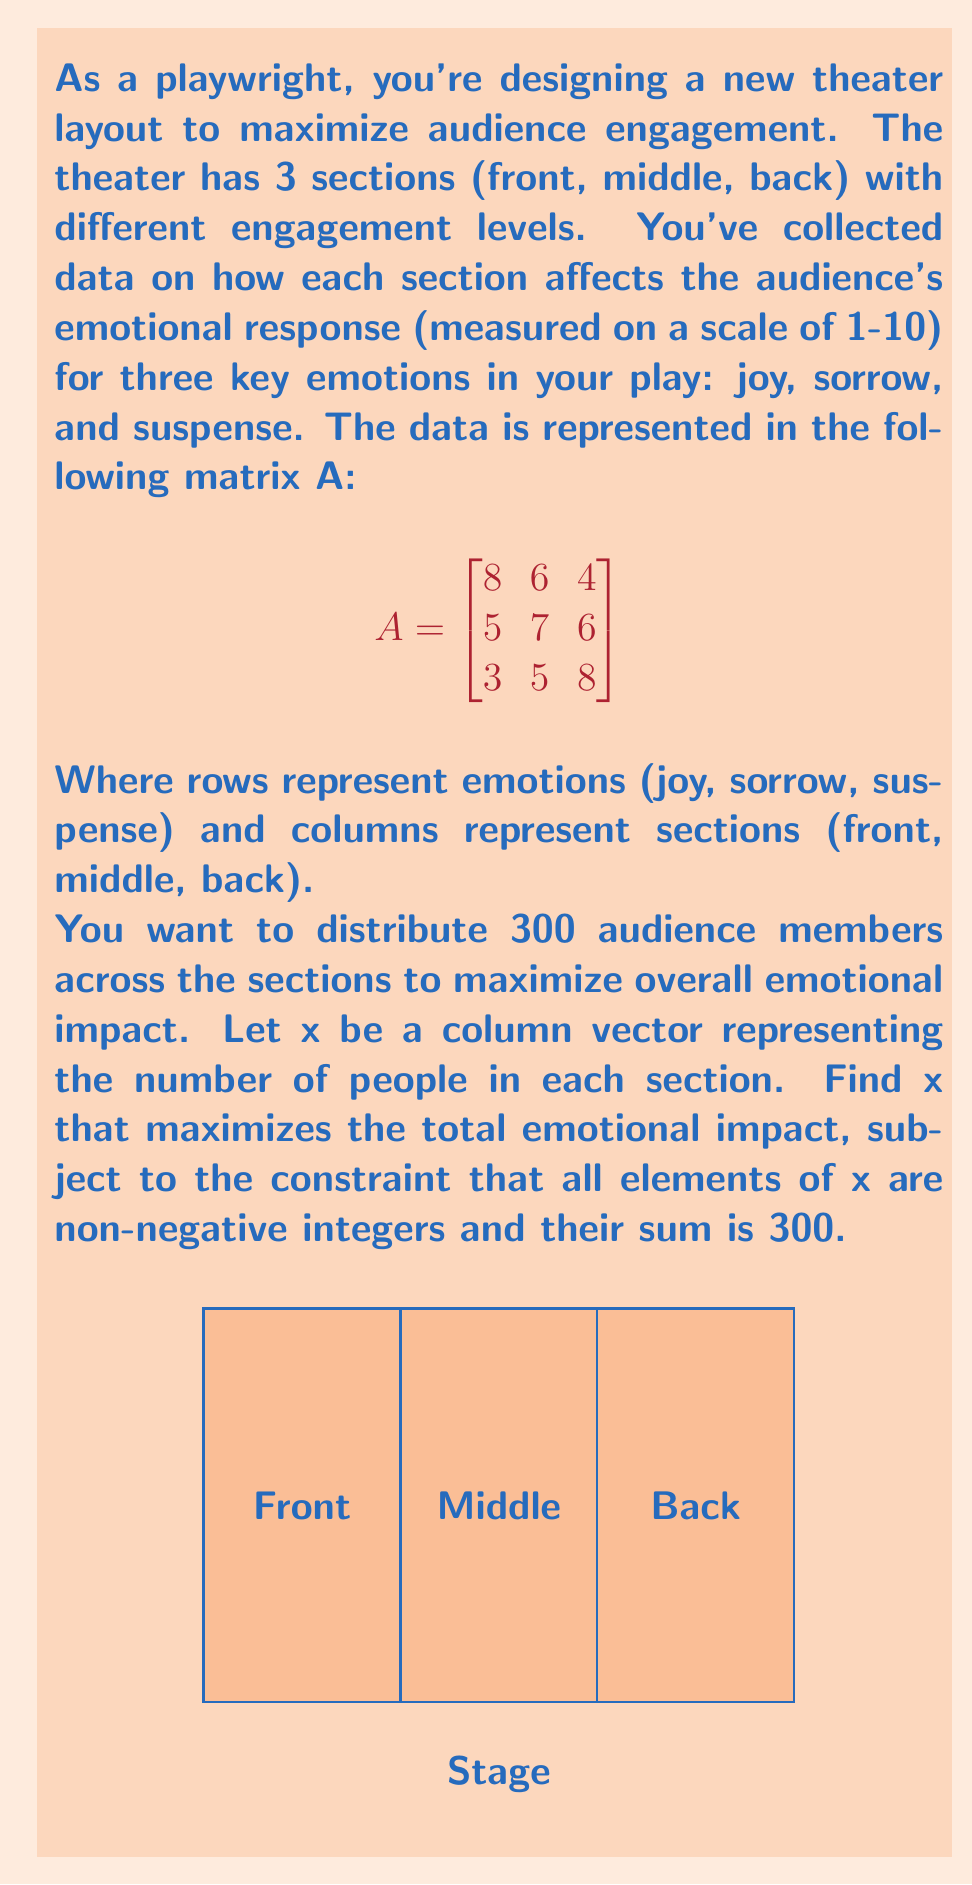Provide a solution to this math problem. To solve this problem, we'll use linear algebra and optimization techniques:

1) The objective function to maximize is $f(x) = Ax$, where $A$ is the given matrix and $x = [x_1, x_2, x_3]^T$ represents the number of people in each section.

2) We need to maximize $f(x) = 8x_1 + 6x_2 + 4x_3 + 5x_1 + 7x_2 + 6x_3 + 3x_1 + 5x_2 + 8x_3$
   $= 16x_1 + 18x_2 + 18x_3$

3) Subject to constraints:
   $x_1 + x_2 + x_3 = 300$
   $x_1, x_2, x_3 \geq 0$ and integers

4) This is an integer linear programming problem. Without the integer constraint, we could solve it using the simplex method. However, given the integer constraint and the simple nature of our problem, we can solve it by reasoning:

   - Each person in the middle or back contributes 18 to the objective function, while each person in the front only contributes 16.
   - Therefore, to maximize the objective function, we should fill the middle and back sections first.

5) The optimal solution is to put as many people as possible in the middle and back sections, split equally (as they contribute equally), and put the remainder in the front:

   $x_2 = x_3 = 150$
   $x_1 = 0$

6) This solution satisfies all constraints and maximizes the objective function.

7) The maximum emotional impact is:
   $16(0) + 18(150) + 18(150) = 5400$
Answer: $x = [0, 150, 150]^T$ 